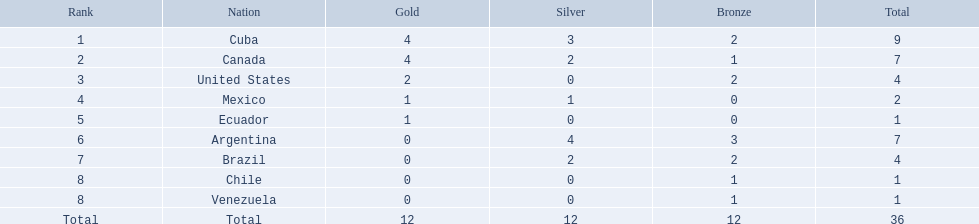Which countries took part? Cuba, Canada, United States, Mexico, Ecuador, Argentina, Brazil, Chile, Venezuela. Which countries secured gold? Cuba, Canada, United States, Mexico, Ecuador. Which countries didn't achieve silver? United States, Ecuador, Chile, Venezuela. From the mentioned nations, which country obtained gold? United States. Which countries have obtained gold medals? Cuba, Canada, United States, Mexico, Ecuador. From this group, which have not won any silver or bronze medals? United States, Ecuador. Among the two previously listed nations, which one has solely earned a gold medal? Ecuador. In the canoeing competition at the 2011 pan american games, which countries earned medals? Cuba, Canada, United States, Mexico, Ecuador, Argentina, Brazil, Chile, Venezuela. From this group, who were the bronze medal winners? Cuba, Canada, United States, Argentina, Brazil, Chile, Venezuela. Which nation claimed the greatest number of bronze medals? Argentina. 